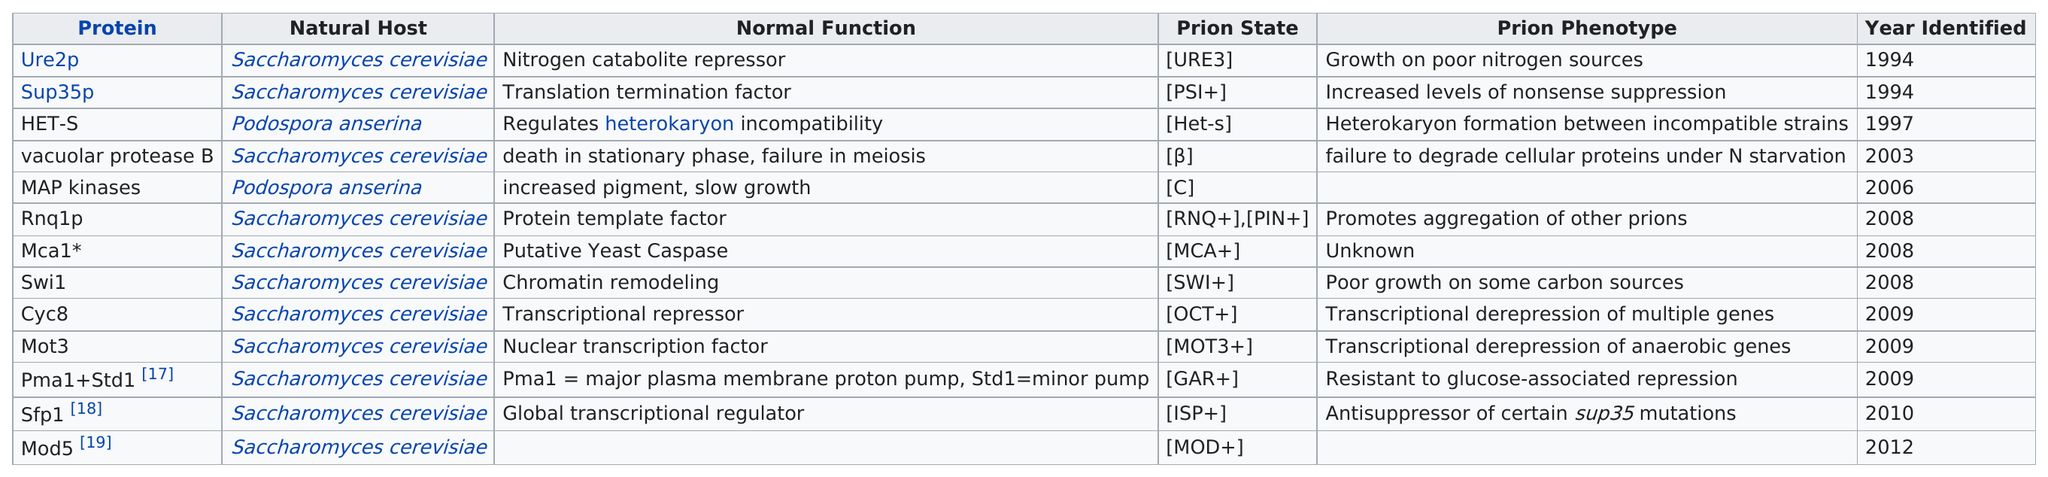Specify some key components in this picture. The protein in question is a vacuolar protease B homolog, referred to as HET-S. The first prion was characterized in 1994. Podospora anserina or Saccharomyces cerevisiae is the natural host for het-s. A total of 13 prions have been thoroughly characterized. The number of proteins from 1994 to 2008 was 8. 